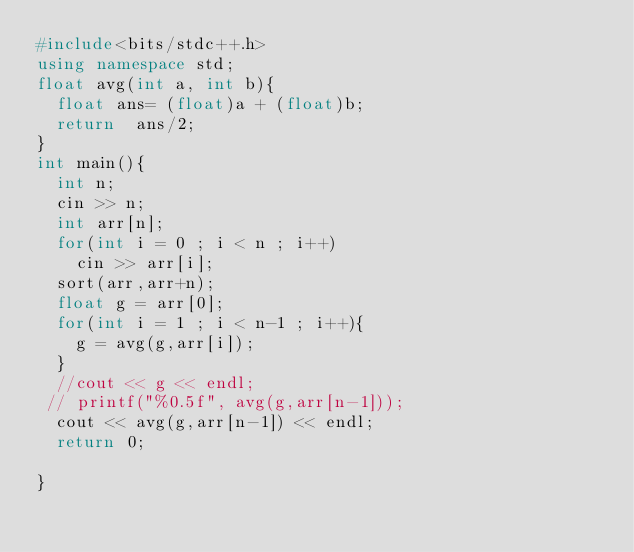Convert code to text. <code><loc_0><loc_0><loc_500><loc_500><_C++_>#include<bits/stdc++.h>
using namespace std;
float avg(int a, int b){
  float ans= (float)a + (float)b;
  return  ans/2;
}
int main(){
  int n;
  cin >> n;
  int arr[n];
  for(int i = 0 ; i < n ; i++)
    cin >> arr[i];
  sort(arr,arr+n);
  float g = arr[0];
  for(int i = 1 ; i < n-1 ; i++){
    g = avg(g,arr[i]);
  }
  //cout << g << endl;
 // printf("%0.5f", avg(g,arr[n-1]));
  cout << avg(g,arr[n-1]) << endl;
  return 0;
  
}</code> 